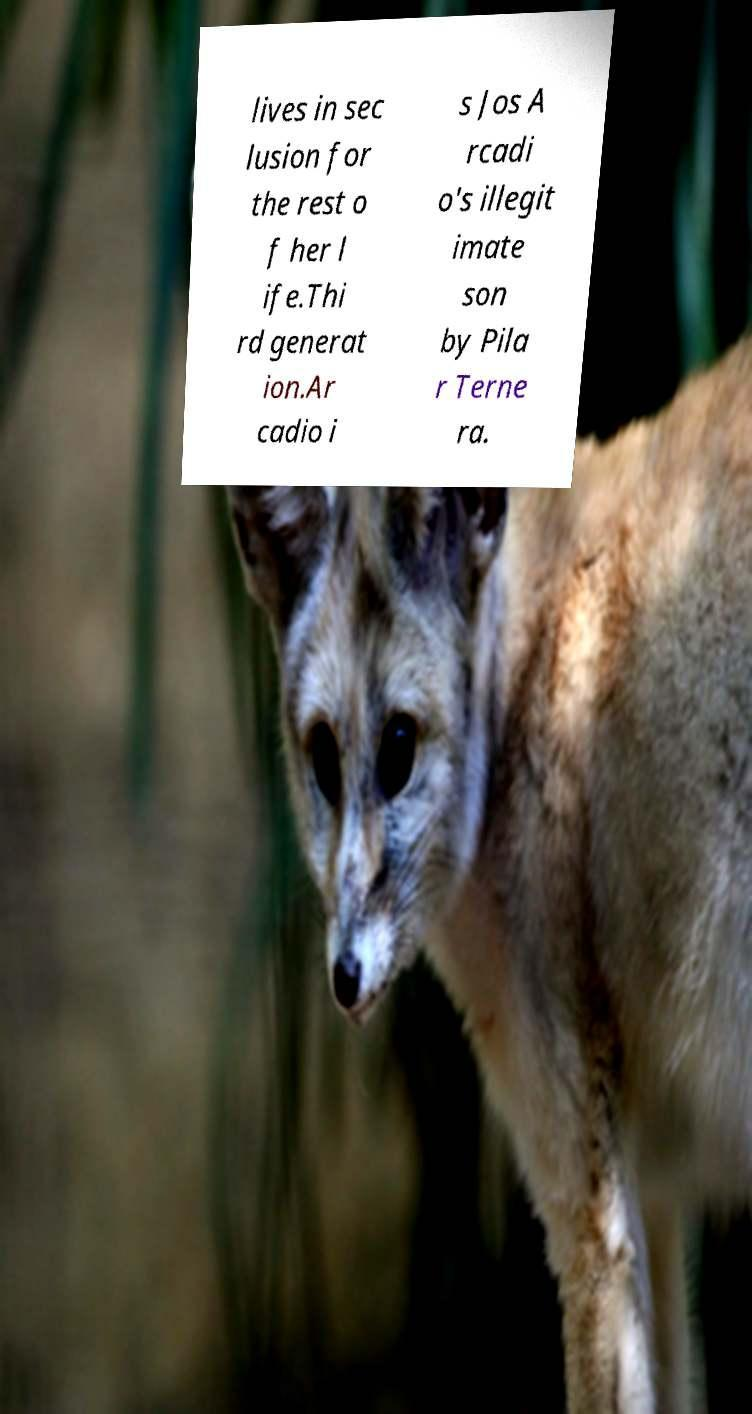Could you assist in decoding the text presented in this image and type it out clearly? lives in sec lusion for the rest o f her l ife.Thi rd generat ion.Ar cadio i s Jos A rcadi o's illegit imate son by Pila r Terne ra. 